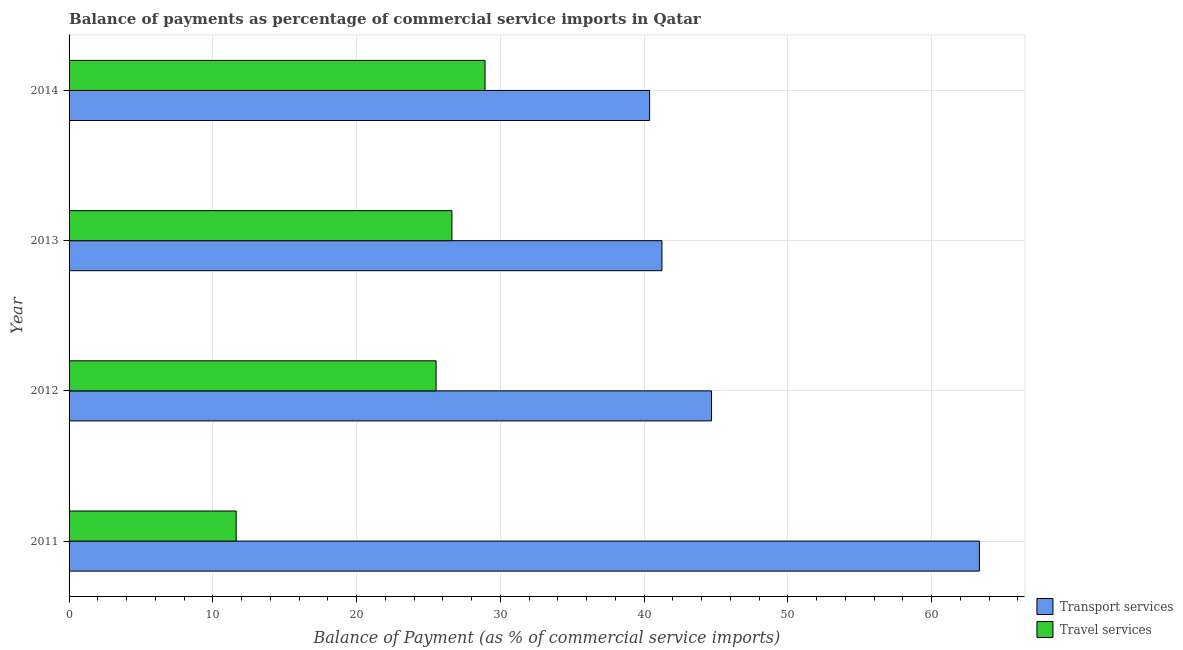How many different coloured bars are there?
Keep it short and to the point. 2. How many groups of bars are there?
Keep it short and to the point. 4. How many bars are there on the 3rd tick from the top?
Provide a succinct answer. 2. What is the label of the 2nd group of bars from the top?
Give a very brief answer. 2013. In how many cases, is the number of bars for a given year not equal to the number of legend labels?
Offer a very short reply. 0. What is the balance of payments of travel services in 2013?
Your response must be concise. 26.63. Across all years, what is the maximum balance of payments of travel services?
Offer a terse response. 28.93. Across all years, what is the minimum balance of payments of transport services?
Ensure brevity in your answer.  40.38. What is the total balance of payments of transport services in the graph?
Keep it short and to the point. 189.63. What is the difference between the balance of payments of transport services in 2012 and that in 2013?
Your response must be concise. 3.45. What is the difference between the balance of payments of travel services in 2012 and the balance of payments of transport services in 2013?
Make the answer very short. -15.71. What is the average balance of payments of transport services per year?
Provide a succinct answer. 47.41. In the year 2013, what is the difference between the balance of payments of travel services and balance of payments of transport services?
Your answer should be compact. -14.61. What is the ratio of the balance of payments of transport services in 2011 to that in 2012?
Offer a very short reply. 1.42. Is the balance of payments of transport services in 2011 less than that in 2013?
Provide a short and direct response. No. What is the difference between the highest and the second highest balance of payments of travel services?
Your answer should be compact. 2.3. What is the difference between the highest and the lowest balance of payments of travel services?
Provide a short and direct response. 17.31. What does the 1st bar from the top in 2013 represents?
Your answer should be compact. Travel services. What does the 2nd bar from the bottom in 2011 represents?
Provide a succinct answer. Travel services. Does the graph contain any zero values?
Ensure brevity in your answer.  No. Does the graph contain grids?
Your response must be concise. Yes. What is the title of the graph?
Keep it short and to the point. Balance of payments as percentage of commercial service imports in Qatar. What is the label or title of the X-axis?
Your answer should be very brief. Balance of Payment (as % of commercial service imports). What is the Balance of Payment (as % of commercial service imports) in Transport services in 2011?
Give a very brief answer. 63.32. What is the Balance of Payment (as % of commercial service imports) in Travel services in 2011?
Give a very brief answer. 11.62. What is the Balance of Payment (as % of commercial service imports) of Transport services in 2012?
Your answer should be compact. 44.69. What is the Balance of Payment (as % of commercial service imports) in Travel services in 2012?
Your answer should be compact. 25.53. What is the Balance of Payment (as % of commercial service imports) in Transport services in 2013?
Ensure brevity in your answer.  41.24. What is the Balance of Payment (as % of commercial service imports) of Travel services in 2013?
Your answer should be very brief. 26.63. What is the Balance of Payment (as % of commercial service imports) in Transport services in 2014?
Provide a succinct answer. 40.38. What is the Balance of Payment (as % of commercial service imports) in Travel services in 2014?
Give a very brief answer. 28.93. Across all years, what is the maximum Balance of Payment (as % of commercial service imports) in Transport services?
Keep it short and to the point. 63.32. Across all years, what is the maximum Balance of Payment (as % of commercial service imports) of Travel services?
Provide a short and direct response. 28.93. Across all years, what is the minimum Balance of Payment (as % of commercial service imports) in Transport services?
Provide a succinct answer. 40.38. Across all years, what is the minimum Balance of Payment (as % of commercial service imports) in Travel services?
Ensure brevity in your answer.  11.62. What is the total Balance of Payment (as % of commercial service imports) in Transport services in the graph?
Offer a terse response. 189.63. What is the total Balance of Payment (as % of commercial service imports) of Travel services in the graph?
Your answer should be compact. 92.71. What is the difference between the Balance of Payment (as % of commercial service imports) of Transport services in 2011 and that in 2012?
Provide a short and direct response. 18.63. What is the difference between the Balance of Payment (as % of commercial service imports) of Travel services in 2011 and that in 2012?
Give a very brief answer. -13.9. What is the difference between the Balance of Payment (as % of commercial service imports) of Transport services in 2011 and that in 2013?
Provide a short and direct response. 22.08. What is the difference between the Balance of Payment (as % of commercial service imports) of Travel services in 2011 and that in 2013?
Give a very brief answer. -15.01. What is the difference between the Balance of Payment (as % of commercial service imports) in Transport services in 2011 and that in 2014?
Keep it short and to the point. 22.94. What is the difference between the Balance of Payment (as % of commercial service imports) in Travel services in 2011 and that in 2014?
Provide a succinct answer. -17.31. What is the difference between the Balance of Payment (as % of commercial service imports) in Transport services in 2012 and that in 2013?
Provide a short and direct response. 3.45. What is the difference between the Balance of Payment (as % of commercial service imports) of Travel services in 2012 and that in 2013?
Provide a short and direct response. -1.1. What is the difference between the Balance of Payment (as % of commercial service imports) of Transport services in 2012 and that in 2014?
Ensure brevity in your answer.  4.31. What is the difference between the Balance of Payment (as % of commercial service imports) of Travel services in 2012 and that in 2014?
Your answer should be compact. -3.4. What is the difference between the Balance of Payment (as % of commercial service imports) of Transport services in 2013 and that in 2014?
Your answer should be compact. 0.86. What is the difference between the Balance of Payment (as % of commercial service imports) of Travel services in 2013 and that in 2014?
Your answer should be very brief. -2.3. What is the difference between the Balance of Payment (as % of commercial service imports) in Transport services in 2011 and the Balance of Payment (as % of commercial service imports) in Travel services in 2012?
Offer a terse response. 37.79. What is the difference between the Balance of Payment (as % of commercial service imports) in Transport services in 2011 and the Balance of Payment (as % of commercial service imports) in Travel services in 2013?
Your answer should be very brief. 36.69. What is the difference between the Balance of Payment (as % of commercial service imports) of Transport services in 2011 and the Balance of Payment (as % of commercial service imports) of Travel services in 2014?
Provide a short and direct response. 34.39. What is the difference between the Balance of Payment (as % of commercial service imports) of Transport services in 2012 and the Balance of Payment (as % of commercial service imports) of Travel services in 2013?
Make the answer very short. 18.06. What is the difference between the Balance of Payment (as % of commercial service imports) of Transport services in 2012 and the Balance of Payment (as % of commercial service imports) of Travel services in 2014?
Your response must be concise. 15.75. What is the difference between the Balance of Payment (as % of commercial service imports) in Transport services in 2013 and the Balance of Payment (as % of commercial service imports) in Travel services in 2014?
Your answer should be compact. 12.31. What is the average Balance of Payment (as % of commercial service imports) in Transport services per year?
Keep it short and to the point. 47.41. What is the average Balance of Payment (as % of commercial service imports) of Travel services per year?
Make the answer very short. 23.18. In the year 2011, what is the difference between the Balance of Payment (as % of commercial service imports) of Transport services and Balance of Payment (as % of commercial service imports) of Travel services?
Your response must be concise. 51.7. In the year 2012, what is the difference between the Balance of Payment (as % of commercial service imports) of Transport services and Balance of Payment (as % of commercial service imports) of Travel services?
Provide a succinct answer. 19.16. In the year 2013, what is the difference between the Balance of Payment (as % of commercial service imports) of Transport services and Balance of Payment (as % of commercial service imports) of Travel services?
Provide a succinct answer. 14.61. In the year 2014, what is the difference between the Balance of Payment (as % of commercial service imports) in Transport services and Balance of Payment (as % of commercial service imports) in Travel services?
Your response must be concise. 11.45. What is the ratio of the Balance of Payment (as % of commercial service imports) in Transport services in 2011 to that in 2012?
Give a very brief answer. 1.42. What is the ratio of the Balance of Payment (as % of commercial service imports) in Travel services in 2011 to that in 2012?
Give a very brief answer. 0.46. What is the ratio of the Balance of Payment (as % of commercial service imports) in Transport services in 2011 to that in 2013?
Provide a short and direct response. 1.54. What is the ratio of the Balance of Payment (as % of commercial service imports) in Travel services in 2011 to that in 2013?
Make the answer very short. 0.44. What is the ratio of the Balance of Payment (as % of commercial service imports) in Transport services in 2011 to that in 2014?
Make the answer very short. 1.57. What is the ratio of the Balance of Payment (as % of commercial service imports) of Travel services in 2011 to that in 2014?
Keep it short and to the point. 0.4. What is the ratio of the Balance of Payment (as % of commercial service imports) in Transport services in 2012 to that in 2013?
Your answer should be compact. 1.08. What is the ratio of the Balance of Payment (as % of commercial service imports) of Travel services in 2012 to that in 2013?
Your answer should be compact. 0.96. What is the ratio of the Balance of Payment (as % of commercial service imports) in Transport services in 2012 to that in 2014?
Your answer should be very brief. 1.11. What is the ratio of the Balance of Payment (as % of commercial service imports) in Travel services in 2012 to that in 2014?
Offer a very short reply. 0.88. What is the ratio of the Balance of Payment (as % of commercial service imports) of Transport services in 2013 to that in 2014?
Your answer should be compact. 1.02. What is the ratio of the Balance of Payment (as % of commercial service imports) in Travel services in 2013 to that in 2014?
Your answer should be compact. 0.92. What is the difference between the highest and the second highest Balance of Payment (as % of commercial service imports) in Transport services?
Provide a succinct answer. 18.63. What is the difference between the highest and the second highest Balance of Payment (as % of commercial service imports) in Travel services?
Your answer should be compact. 2.3. What is the difference between the highest and the lowest Balance of Payment (as % of commercial service imports) of Transport services?
Give a very brief answer. 22.94. What is the difference between the highest and the lowest Balance of Payment (as % of commercial service imports) in Travel services?
Offer a very short reply. 17.31. 